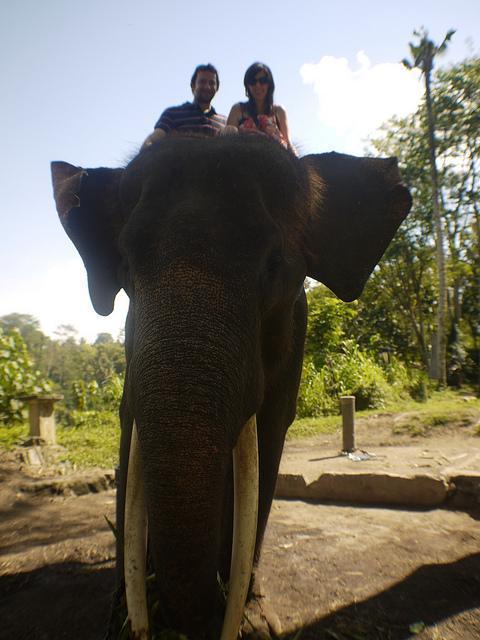Where can you find this animal?
Pick the correct solution from the four options below to address the question.
Options: New jersey, india, siberia, russia. India. 